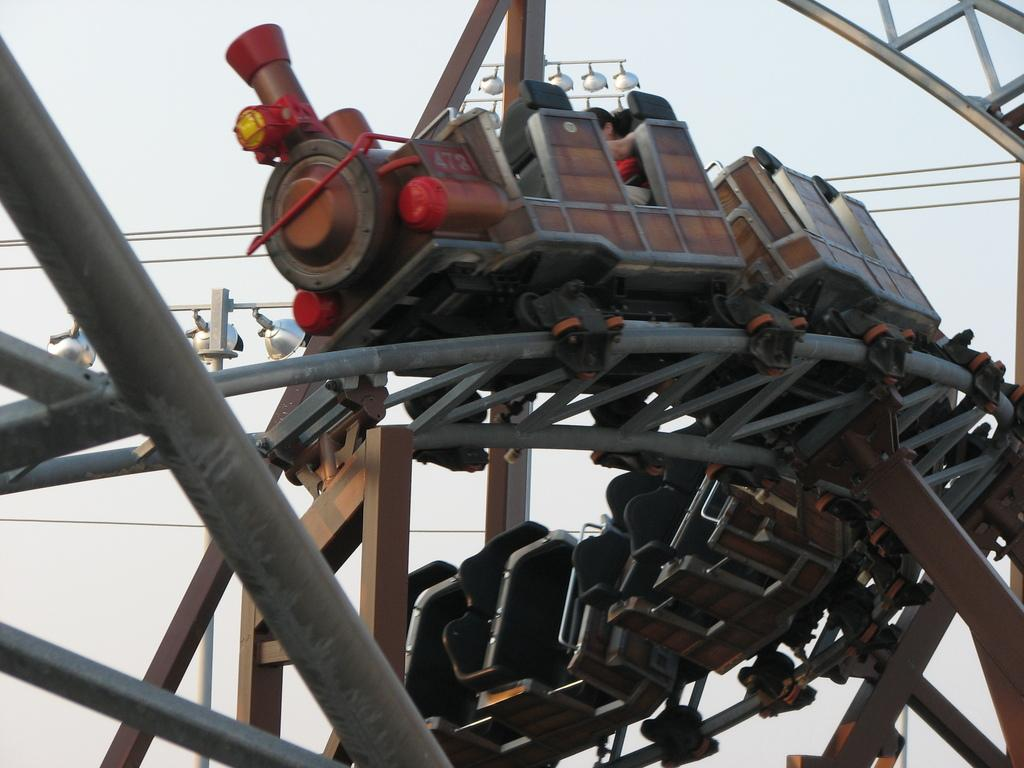What is the main subject in the foreground of the image? There is a roller coaster in the foreground of the image. How is the roller coaster moving in the image? The roller coaster is moving on a rail in the image. What can be seen in the background of the image? There are light poles, cables, and the sky visible in the background of the image. How many legs does the bear have in the image? There is no bear present in the image, so it is not possible to determine the number of legs it might have. 